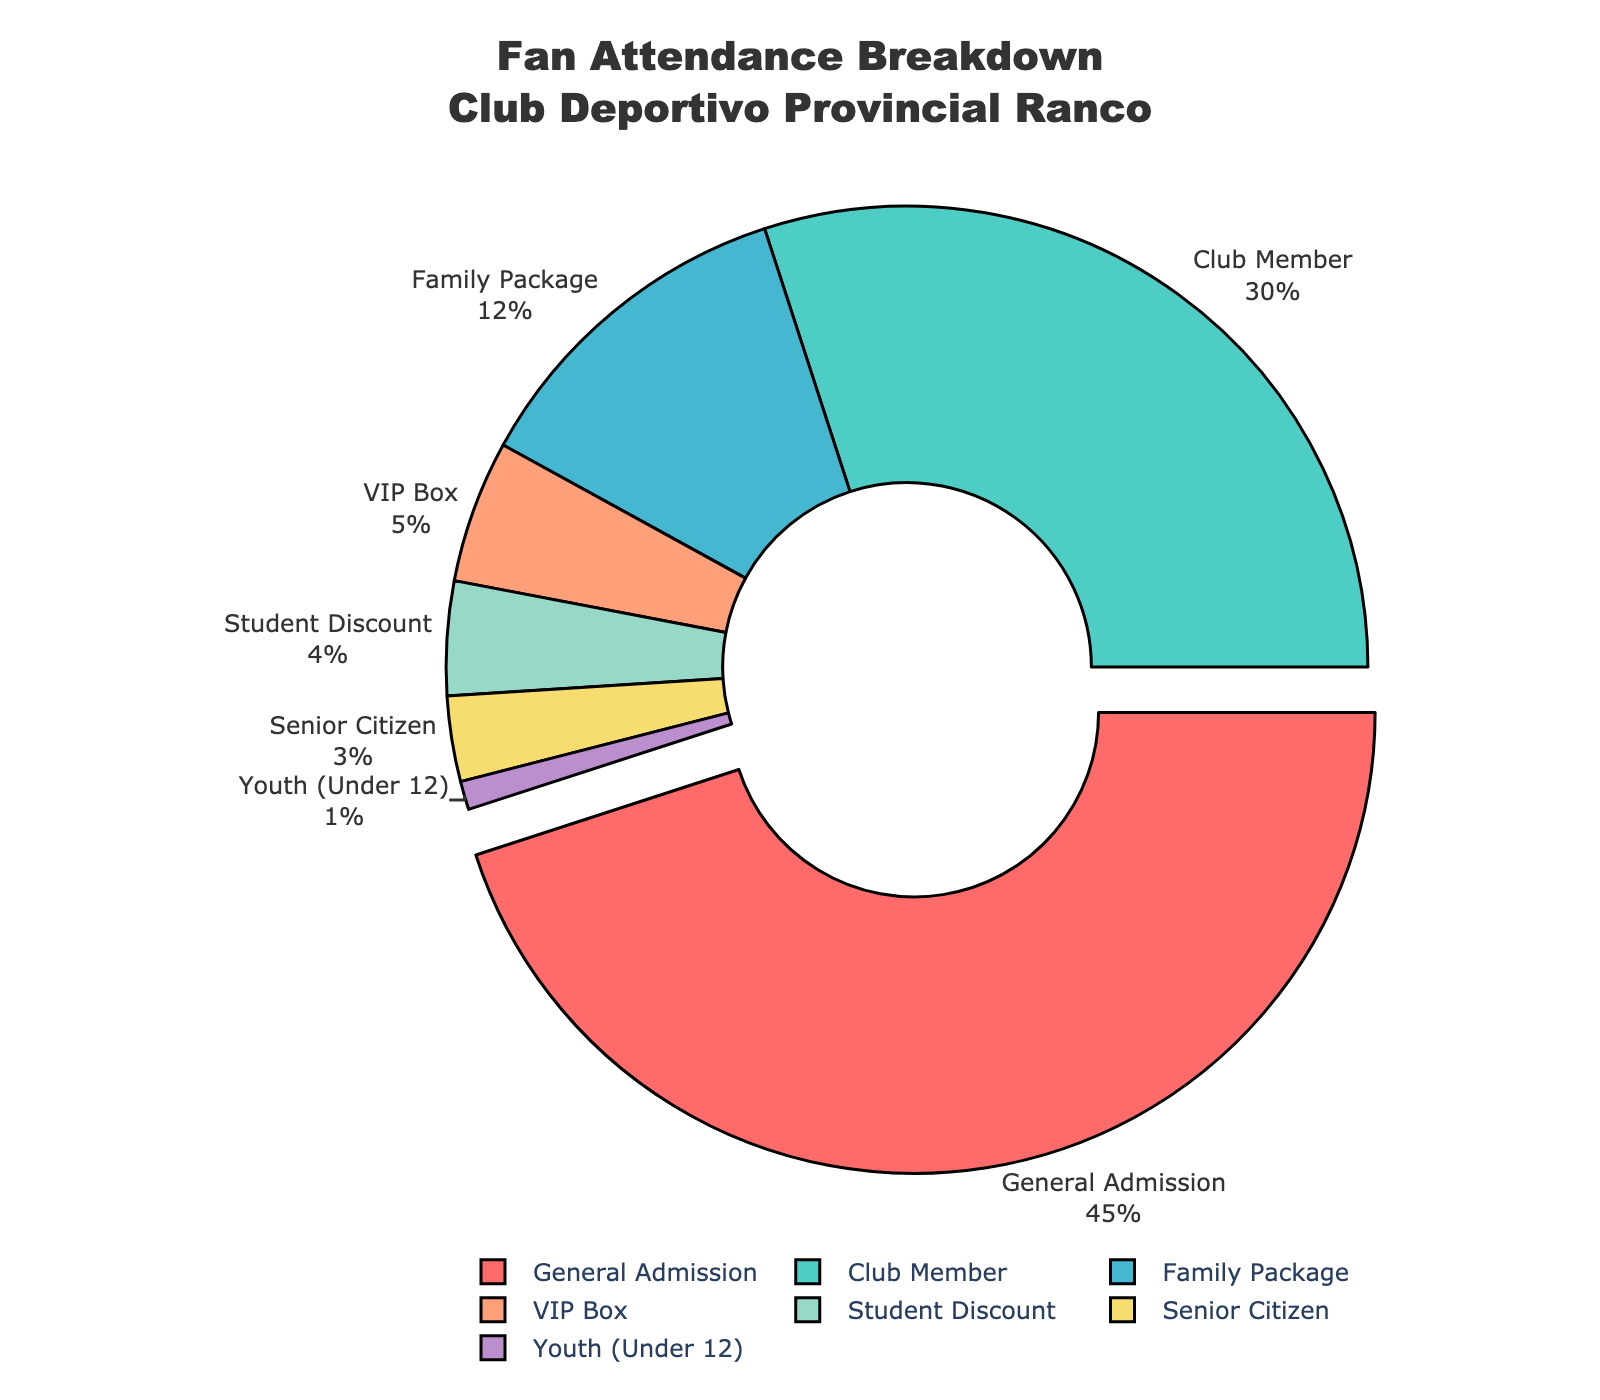what percentage of attendees are Club Members? By referring to the section labeled "Club Member" in the pie chart, we see that it accounts for 30% of the attendees.
Answer: 30% Which ticket type has the largest percentage of attendees? The pie chart uses different colors and labels to show the segments. By observing the chart, the largest segment is "General Admission," accounting for 45% of the attendees.
Answer: General Admission What is the combined percentage of attendees who use the Family Package, Student Discount, and Senior Citizen tickets? To find the combined percentage, we sum the individual percentages of the desired segments: Family Package (12%) + Student Discount (4%) + Senior Citizen (3%) = 19%.
Answer: 19% Is the percentage of Youth (Under 12) attendees greater than or equal to 2%? By looking at the pie chart segment for "Youth (Under 12)," we see it accounts for 1% of the attendees, which is less than 2%.
Answer: No What is the difference in percentage between VIP Box and Club Member attendees? The percentage for Club Member is 30% and for VIP Box is 5%. By subtracting these values, we find the difference is 30% - 5% = 25%.
Answer: 25% How does the size of the General Admission segment visually compare to the Senior Citizen segment? The General Admission segment takes up a significantly larger portion of the pie chart compared to the small sliver representing the Senior Citizen segment.
Answer: Much larger If ticket types with less than 5% are merged into an "Other" category, what would the new percentage for this category be? We combine the percentages of Youth (1%), Senior Citizen (3%), and Student Discount (4%), resulting in 1% + 3% + 4% = 8%.
Answer: 8% Among Student Discount and VIP Box, which one has a higher percentage, and by how much? VIP Box accounts for 5%, while Student Discount accounts for 4%. The difference is 5% - 4% = 1%.
Answer: VIP Box by 1% How does the pie chart visually highlight the ticket type with the maximum percentage? The segment for General Admission, which has the maximum percentage (45%), is slightly pulled out from the pie chart, making it more prominent.
Answer: Pulled out What percentage of attendees do not require a discount or special package (General Admission + Club Member)? Adding the percentages for General Admission (45%) and Club Member (30%) gives us 45% + 30% = 75%.
Answer: 75% 